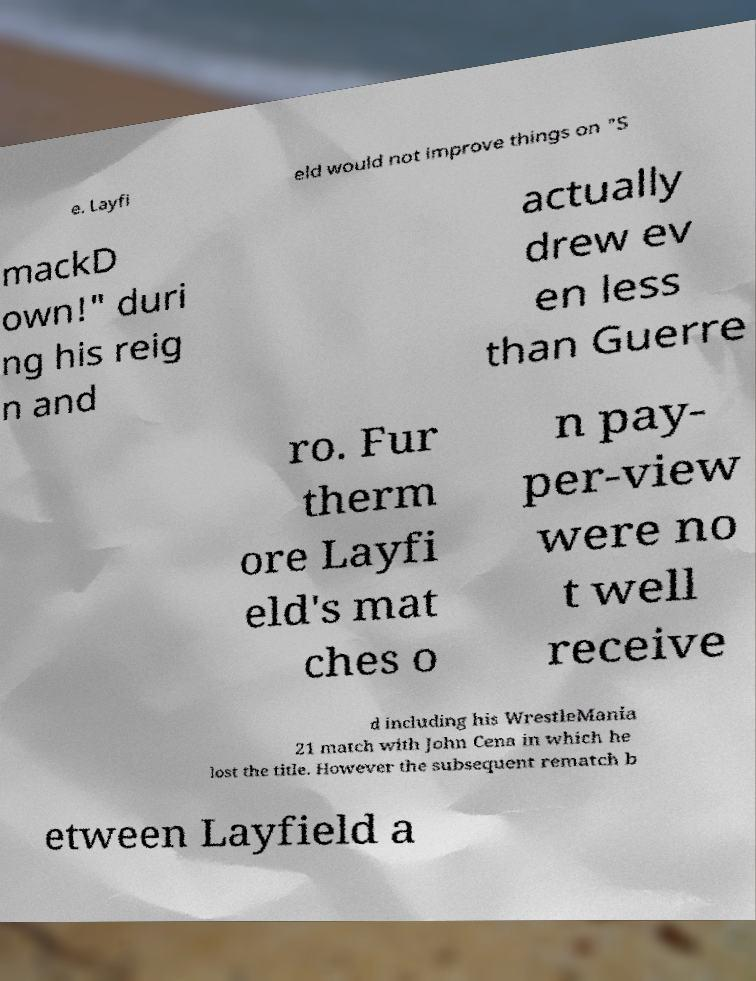Could you extract and type out the text from this image? e. Layfi eld would not improve things on "S mackD own!" duri ng his reig n and actually drew ev en less than Guerre ro. Fur therm ore Layfi eld's mat ches o n pay- per-view were no t well receive d including his WrestleMania 21 match with John Cena in which he lost the title. However the subsequent rematch b etween Layfield a 